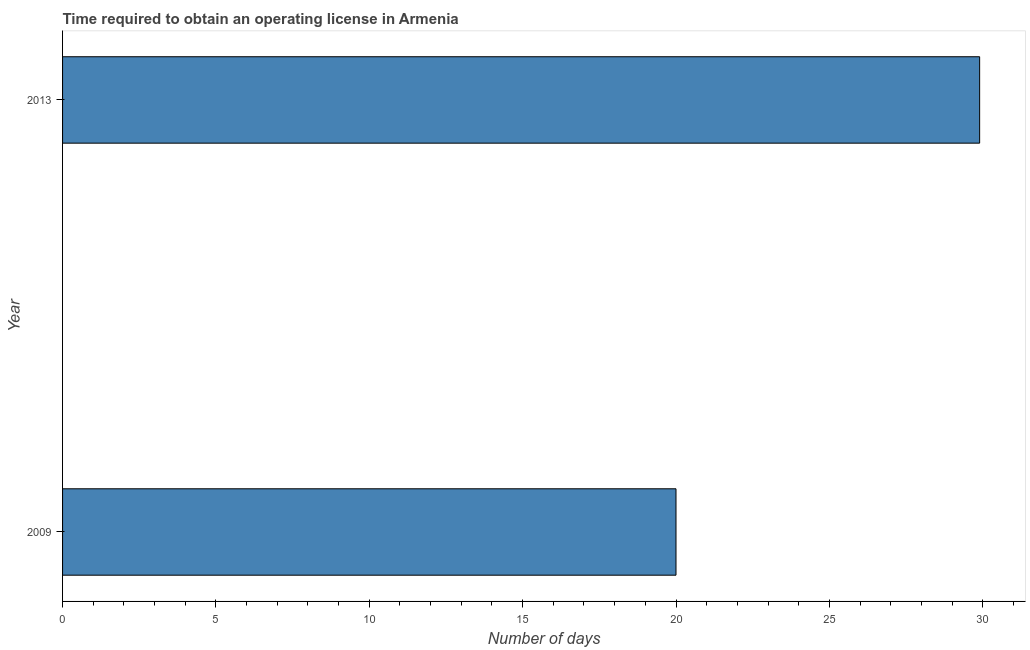Does the graph contain grids?
Provide a short and direct response. No. What is the title of the graph?
Keep it short and to the point. Time required to obtain an operating license in Armenia. What is the label or title of the X-axis?
Offer a terse response. Number of days. What is the label or title of the Y-axis?
Your answer should be very brief. Year. What is the number of days to obtain operating license in 2013?
Provide a short and direct response. 29.9. Across all years, what is the maximum number of days to obtain operating license?
Your response must be concise. 29.9. Across all years, what is the minimum number of days to obtain operating license?
Your answer should be compact. 20. In which year was the number of days to obtain operating license maximum?
Make the answer very short. 2013. In which year was the number of days to obtain operating license minimum?
Your answer should be very brief. 2009. What is the sum of the number of days to obtain operating license?
Your response must be concise. 49.9. What is the difference between the number of days to obtain operating license in 2009 and 2013?
Make the answer very short. -9.9. What is the average number of days to obtain operating license per year?
Provide a succinct answer. 24.95. What is the median number of days to obtain operating license?
Offer a very short reply. 24.95. What is the ratio of the number of days to obtain operating license in 2009 to that in 2013?
Your answer should be compact. 0.67. In how many years, is the number of days to obtain operating license greater than the average number of days to obtain operating license taken over all years?
Provide a short and direct response. 1. Are all the bars in the graph horizontal?
Provide a short and direct response. Yes. Are the values on the major ticks of X-axis written in scientific E-notation?
Provide a succinct answer. No. What is the Number of days of 2013?
Make the answer very short. 29.9. What is the ratio of the Number of days in 2009 to that in 2013?
Your response must be concise. 0.67. 